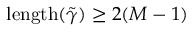<formula> <loc_0><loc_0><loc_500><loc_500>l e n g t h ( \tilde { \gamma } ) \geq 2 ( M - 1 )</formula> 